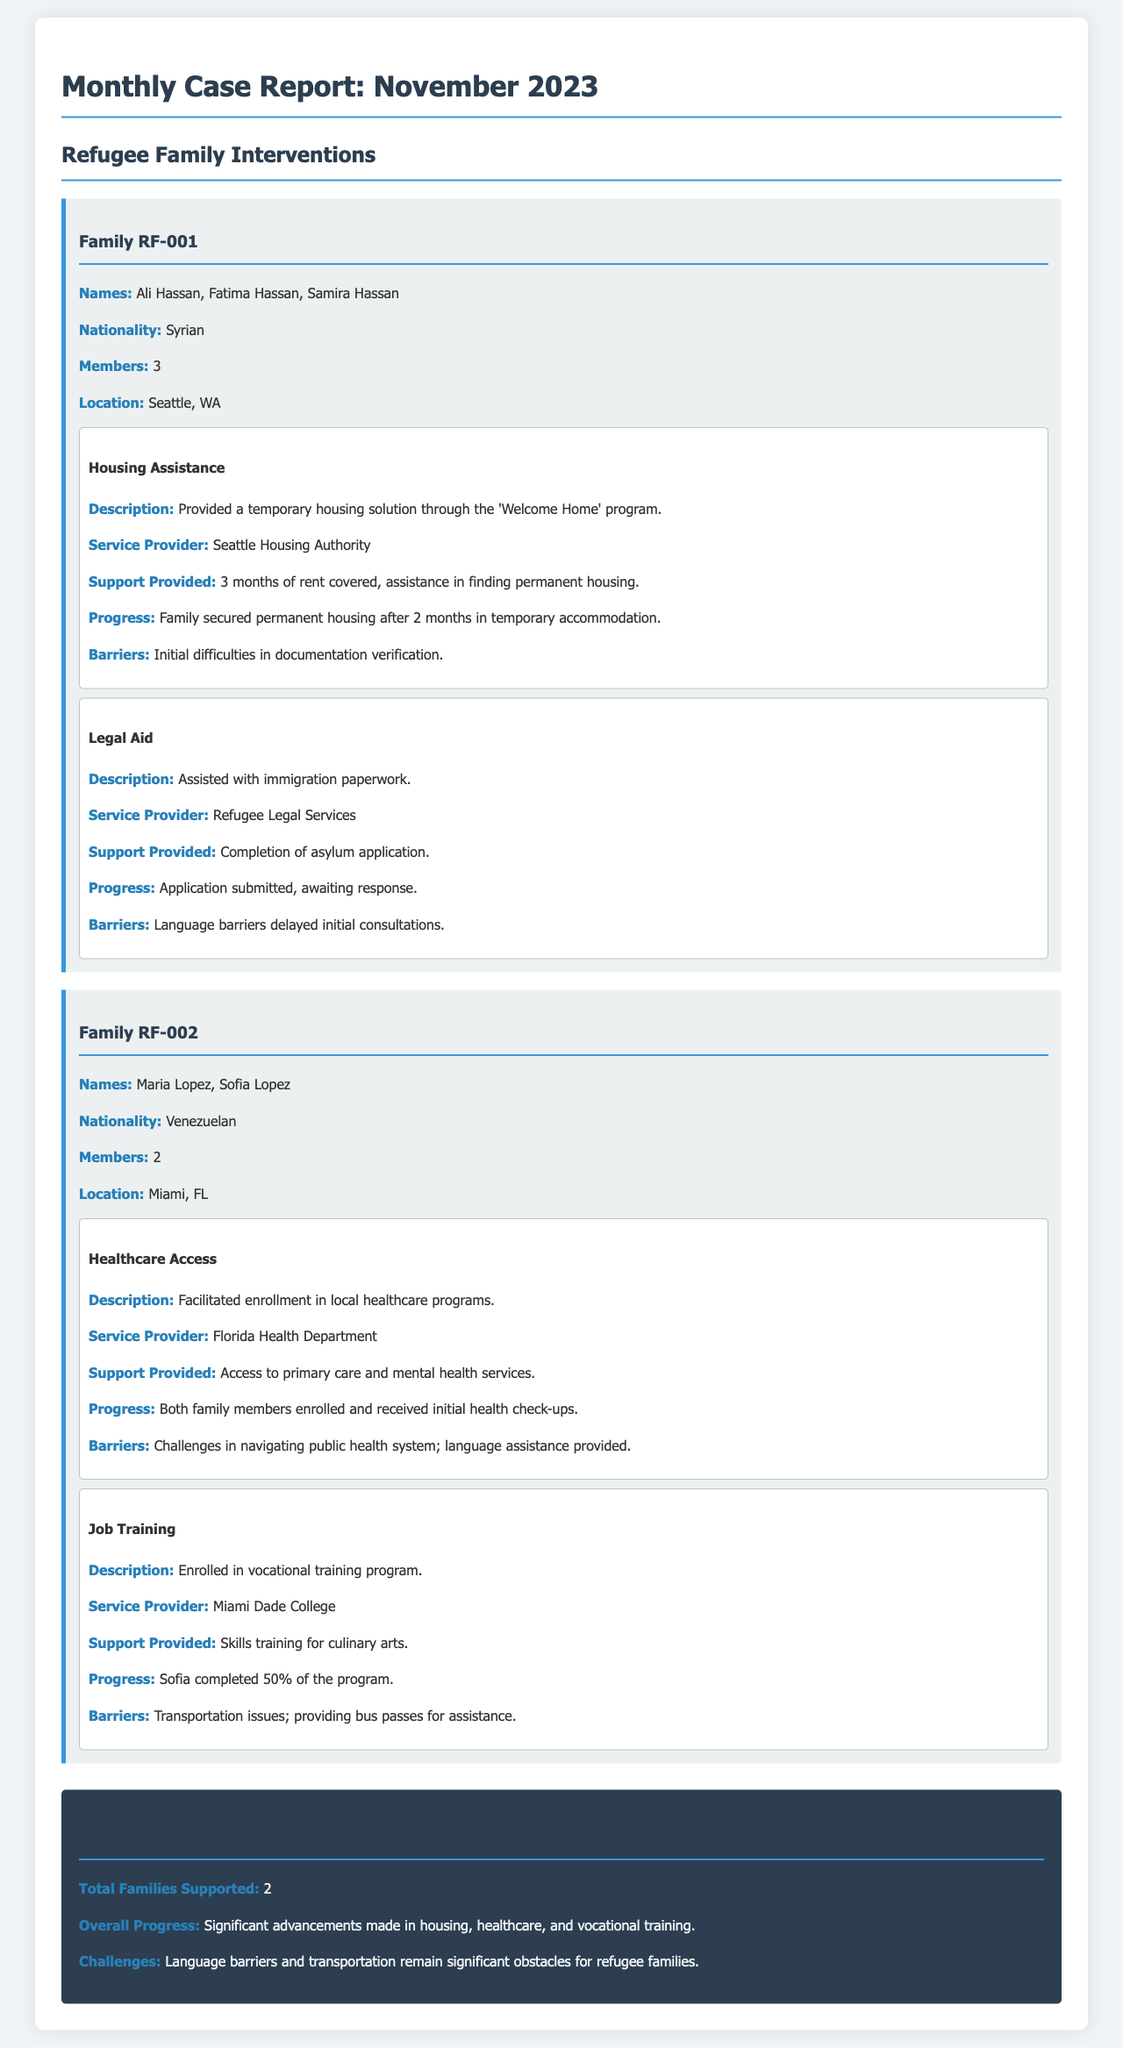What is the nationality of Family RF-001? The nationality is provided in the family card for RF-001, which is Syrian.
Answer: Syrian What type of assistance was provided to Family RF-002? The document lists multiple types of assistance for Family RF-002, including healthcare access and job training.
Answer: Healthcare Access, Job Training How many members are in Family RF-001? The number of family members is clearly stated in the family card for RF-001, which indicates there are 3 members.
Answer: 3 What progress did Family RF-001 make regarding housing? The progress made by Family RF-001 in relation to housing is summarized in the intervention section, stating that they secured permanent housing after 2 months.
Answer: Secured permanent housing after 2 months What barriers did Family RF-002 face concerning transportation? The document specifies the transportation issues faced by Family RF-002, which includes challenges getting to the training program that necessitated the provision of bus passes.
Answer: Transportation issues How long is the housing assistance provided to Family RF-001? The period of housing assistance is mentioned in the intervention details for Family RF-001, stating it was provided for 3 months.
Answer: 3 months How many families were supported in total? The overall total of families supported is summarized at the end of the report, which is 2 families in total.
Answer: 2 What type of legal support was provided to Family RF-001? The legal aid provided to Family RF-001 is detailed in the additional support section, focusing on immigration paperwork assistance.
Answer: Immigration paperwork assistance 